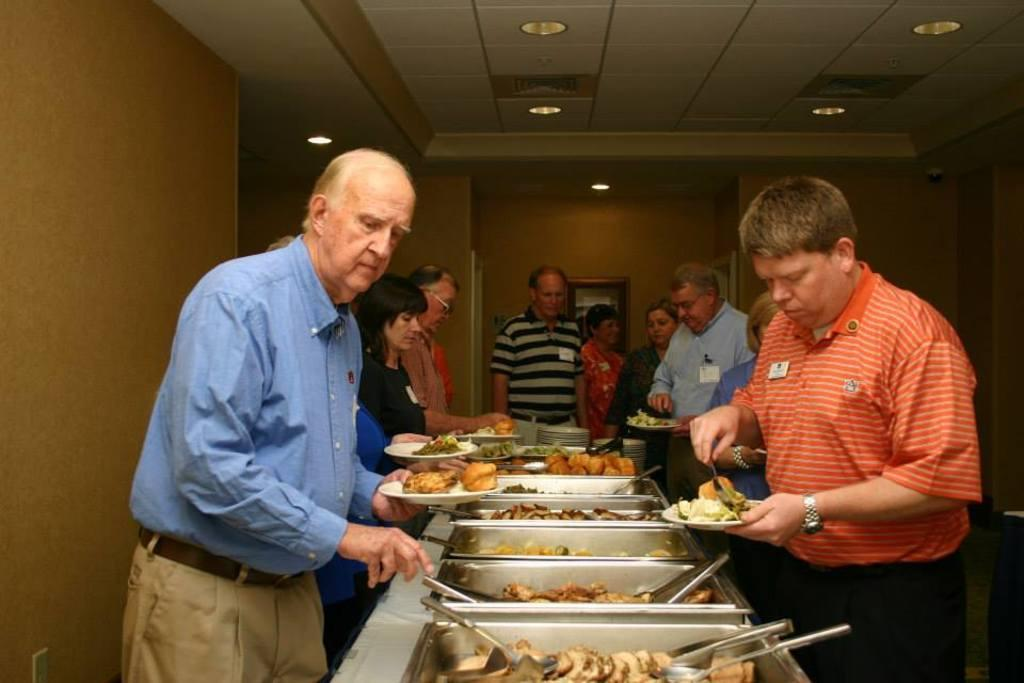Who or what is present in the image? There are people in the image. What can be seen on a plate in the image? There are food items on a plate in the image. What is visible at the top of the image? There are lights visible at the top of the image. What type of fruit is being used as a behavioral aid for the people in the image? There is no fruit present in the image, and no fruit is being used as a behavioral aid for the people. 